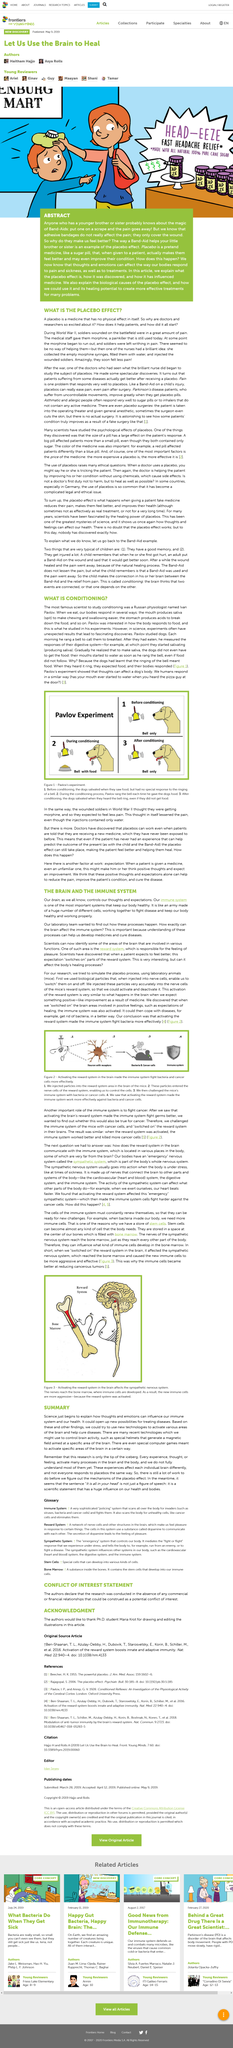Outline some significant characteristics in this image. Morphine, a painkiller used during World War II, is still used today. Head-eeze is a product made with all natural 100% cane sugar as its primary ingredient. The brain is the part of our body that is responsible for controlling our thoughts and expectations. It is imperative that we utilize cutting-edge technologies in order to activate various areas of the brain and aid in the cure of diseases. The laboratory team desires to comprehend the relationship between the brain and the immune system, specifically how the brain can influence the functioning of the immune system. 